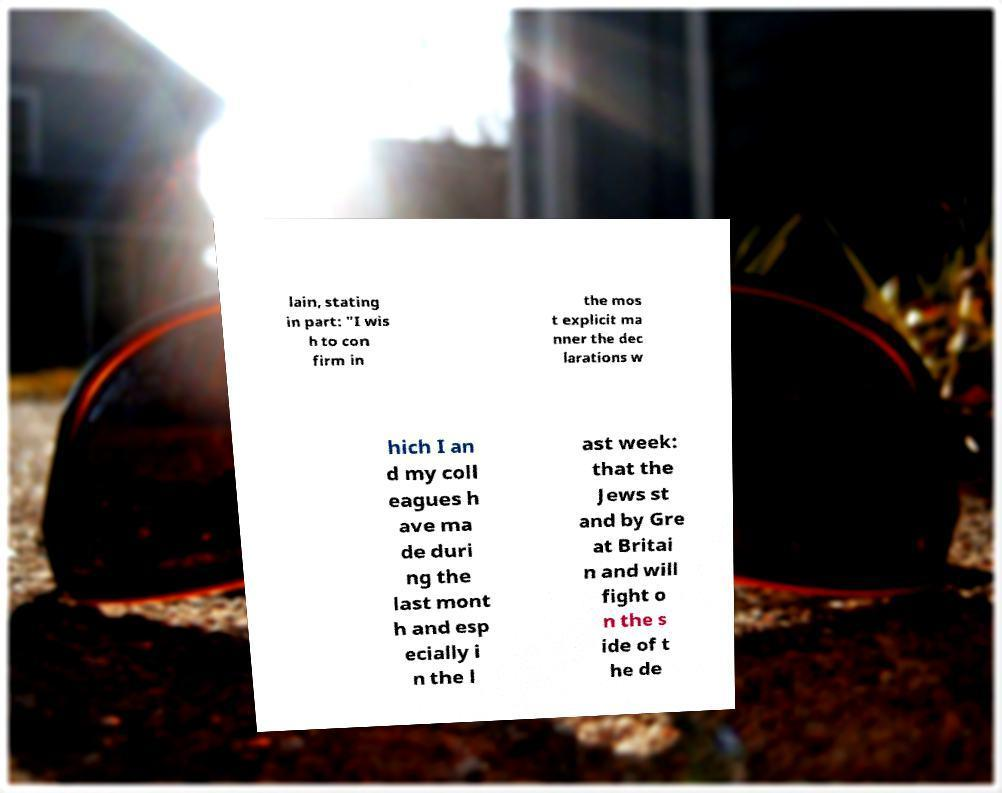For documentation purposes, I need the text within this image transcribed. Could you provide that? lain, stating in part: "I wis h to con firm in the mos t explicit ma nner the dec larations w hich I an d my coll eagues h ave ma de duri ng the last mont h and esp ecially i n the l ast week: that the Jews st and by Gre at Britai n and will fight o n the s ide of t he de 